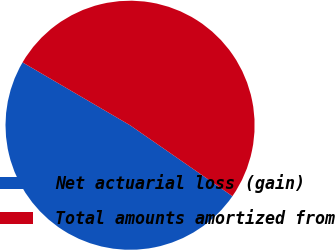<chart> <loc_0><loc_0><loc_500><loc_500><pie_chart><fcel>Net actuarial loss (gain)<fcel>Total amounts amortized from<nl><fcel>48.78%<fcel>51.22%<nl></chart> 